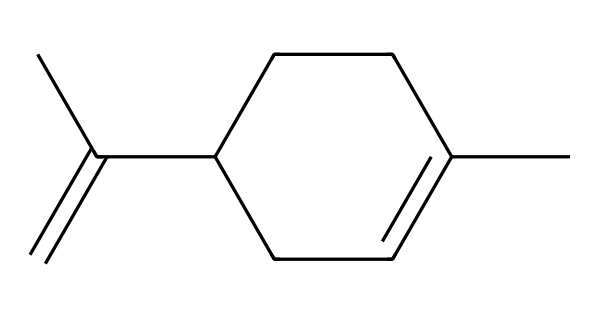What is the name of this chemical? The SMILES representation corresponds to the structure of limonene, a well-known terpene commonly found in citrus fruits.
Answer: limonene How many carbon atoms are in limonene? By analyzing the structure represented in the SMILES, there are a total of 10 carbon atoms (C) present.
Answer: 10 What type of bonding is predominant in limonene? The structure includes single (σ) and double (π) bonds, but the presence of a double bond indicates that alkene bonding is significant in this terpene.
Answer: alkene What is the molecular formula of limonene? Using the carbon (10), hydrogen is determined by the formula CnH2n, so with 10 carbons, hydrogen would be 18: C10H18.
Answer: C10H18 What functional groups are present in limonene? The structure shows a carbon-carbon double bond indicating that it has an alkene functional group, characteristic of terpenes.
Answer: alkene How many rings are in the structure of limonene? Evaluating the structure shows that there is one cycloalkane ring in limonene, making it a cyclic compound.
Answer: 1 Is limonene a saturated or unsaturated compound? The presence of a double bond in its structure indicates that limonene is an unsaturated compound.
Answer: unsaturated 